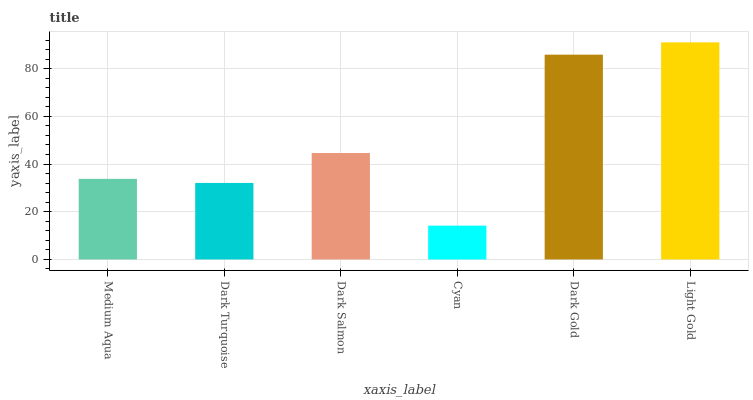Is Cyan the minimum?
Answer yes or no. Yes. Is Light Gold the maximum?
Answer yes or no. Yes. Is Dark Turquoise the minimum?
Answer yes or no. No. Is Dark Turquoise the maximum?
Answer yes or no. No. Is Medium Aqua greater than Dark Turquoise?
Answer yes or no. Yes. Is Dark Turquoise less than Medium Aqua?
Answer yes or no. Yes. Is Dark Turquoise greater than Medium Aqua?
Answer yes or no. No. Is Medium Aqua less than Dark Turquoise?
Answer yes or no. No. Is Dark Salmon the high median?
Answer yes or no. Yes. Is Medium Aqua the low median?
Answer yes or no. Yes. Is Medium Aqua the high median?
Answer yes or no. No. Is Light Gold the low median?
Answer yes or no. No. 